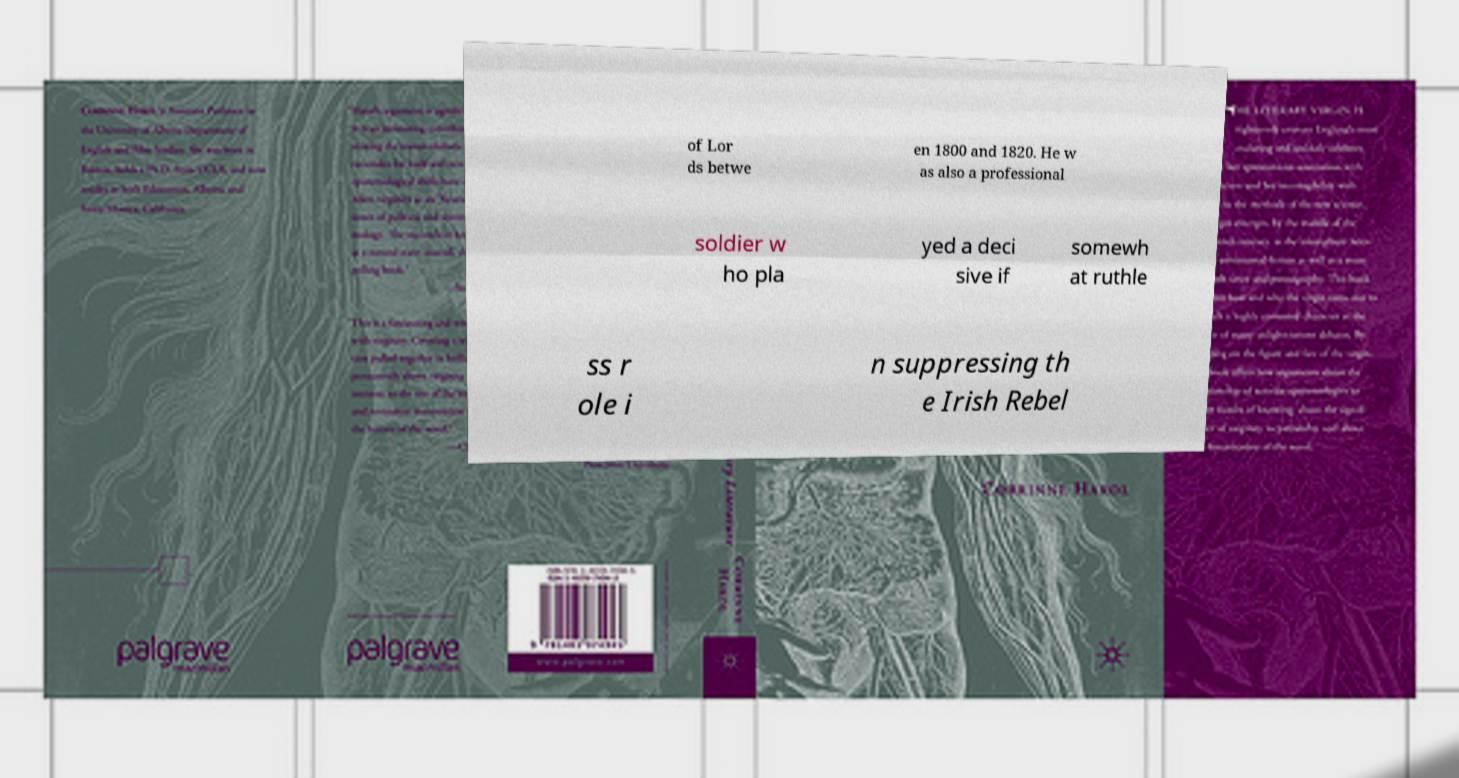For documentation purposes, I need the text within this image transcribed. Could you provide that? of Lor ds betwe en 1800 and 1820. He w as also a professional soldier w ho pla yed a deci sive if somewh at ruthle ss r ole i n suppressing th e Irish Rebel 